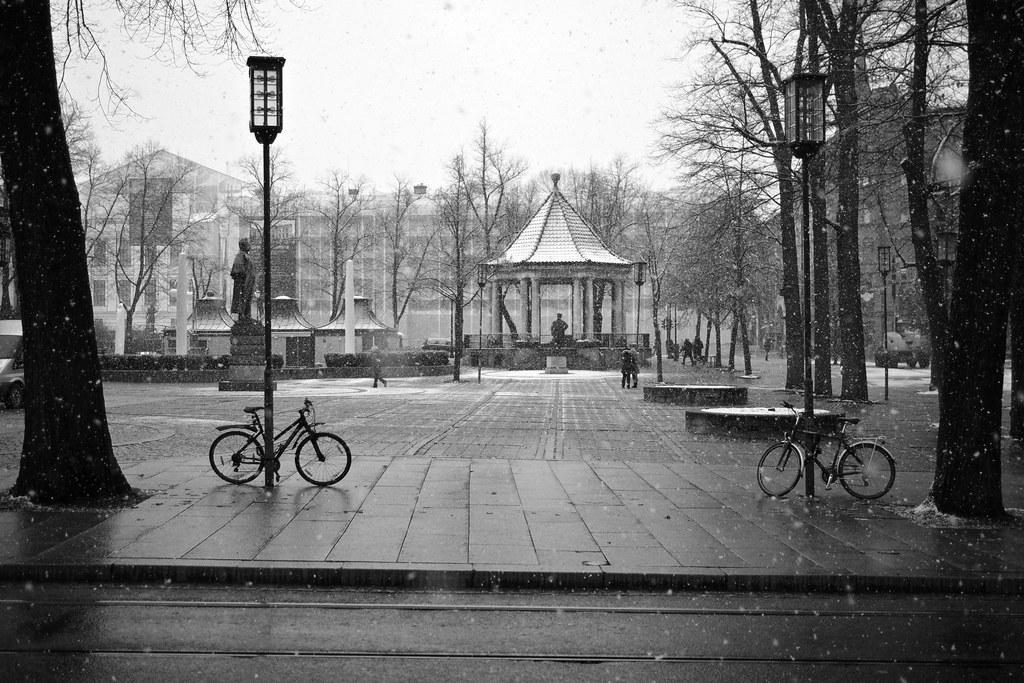Describe this image in one or two sentences. This looks like a black and white image. There are two bicycles, which are parked. I think these are the light poles. I can see the trees. There are few people standing. I think this is a sculpture, which is on the pillar. This looks like a shelter. In the background, I can see a building. This is the sky. This looks like a pathway. On the right side of the image, I can see a vehicle on the road. 